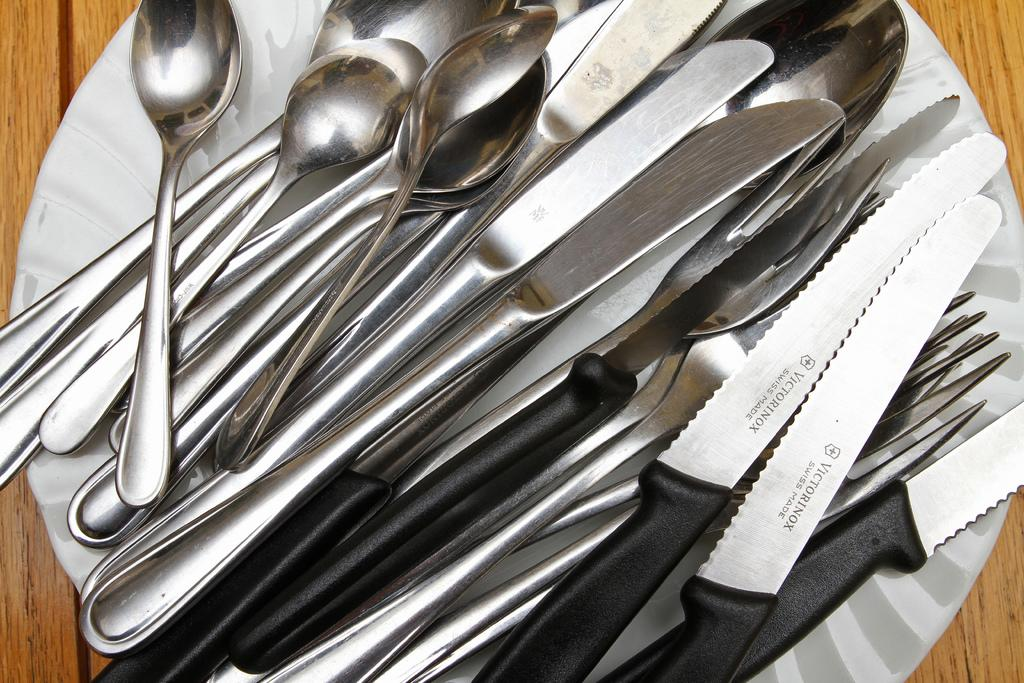What types of utensils are visible in the image? There are spoons, forks, and knives in the image. What is the purpose of the utensils in the image? The utensils are likely used for eating, as they are commonly used for cutting, scooping, and spearing food. What is the plate used for in the image? The plate is likely used for holding or serving food. What is the platform in the image used for? The platform in the image might be used for holding or displaying the plate and utensils. How many brothers are depicted in the image? There are no people, including brothers, present in the image. 